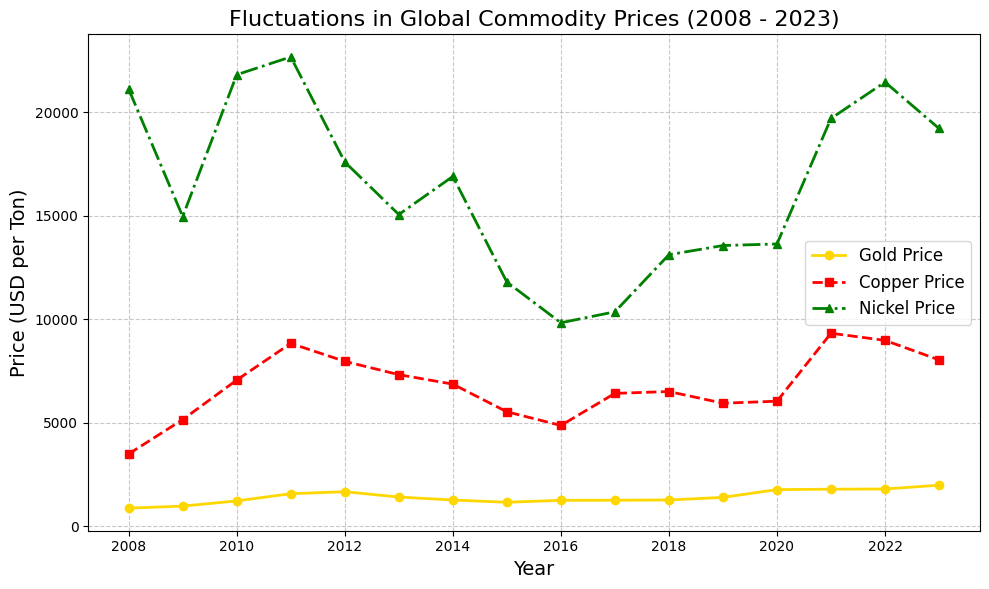What was the price trend of gold between 2008 and 2023? The gold price shows an overall upward trend from $873.64 in 2008 to $1981.25 in 2023, despite some fluctuations over the years.
Answer: Upward In which year did copper have the highest price, and what was its value? By observing the plot, copper reached its highest price in 2011 with a value of $8831.88.
Answer: 2011, $8831.88 How does the 2023 price of nickel compare to its price in 2008? The price of nickel in 2023 is $19211, which is lower than its price in 2008, which was $21110.
Answer: Lower What's the average price of gold over the 15-year period? Sum all the gold prices from 2008 to 2023 and divide by 16 (number of years): (873.64 + 972.35 + 1224.52 + 1571.52 + 1668.12 + 1411.23 + 1266.06 + 1157.83 + 1250.74 + 1257.12 + 1268.93 + 1393.34 + 1769.59 + 1789.12 + 1800.50 + 1981.25) / 16 = 1365.665
Answer: 1365.67 Which metal showed the most price volatility over the plotted years? By observing the fluctuation ranges in the plot, nickel shows the most volatility, with a significant drop and rise in prices over the years.
Answer: Nickel Between which consecutive years did copper prices have the biggest increase? The plot indicates the biggest increase occurred between 2008 and 2009, where copper prices rose from $3492.61 to $5150.97.
Answer: 2008-2009 What was the price of gold in 2011 compared to 2018? The price of gold in 2011 was $1571.52, which is higher than its price in 2018 at $1268.93.
Answer: Higher How did the price of copper change from 2021 to 2022? The price of copper decreased from $9321.27 in 2021 to $8976.77 in 2022.
Answer: Decreased Of the three minerals, which was the least expensive in 2015? In 2015, the prices are: gold $1157.83, copper $5528.74, nickel $11795. Gold was the least expensive.
Answer: Gold What is the difference in nickel prices between 2010 and 2015? The price of nickel in 2010 was $21808 while in 2015 it was $11795, so the difference is 21808 - 11795 = 10013.
Answer: 10013 